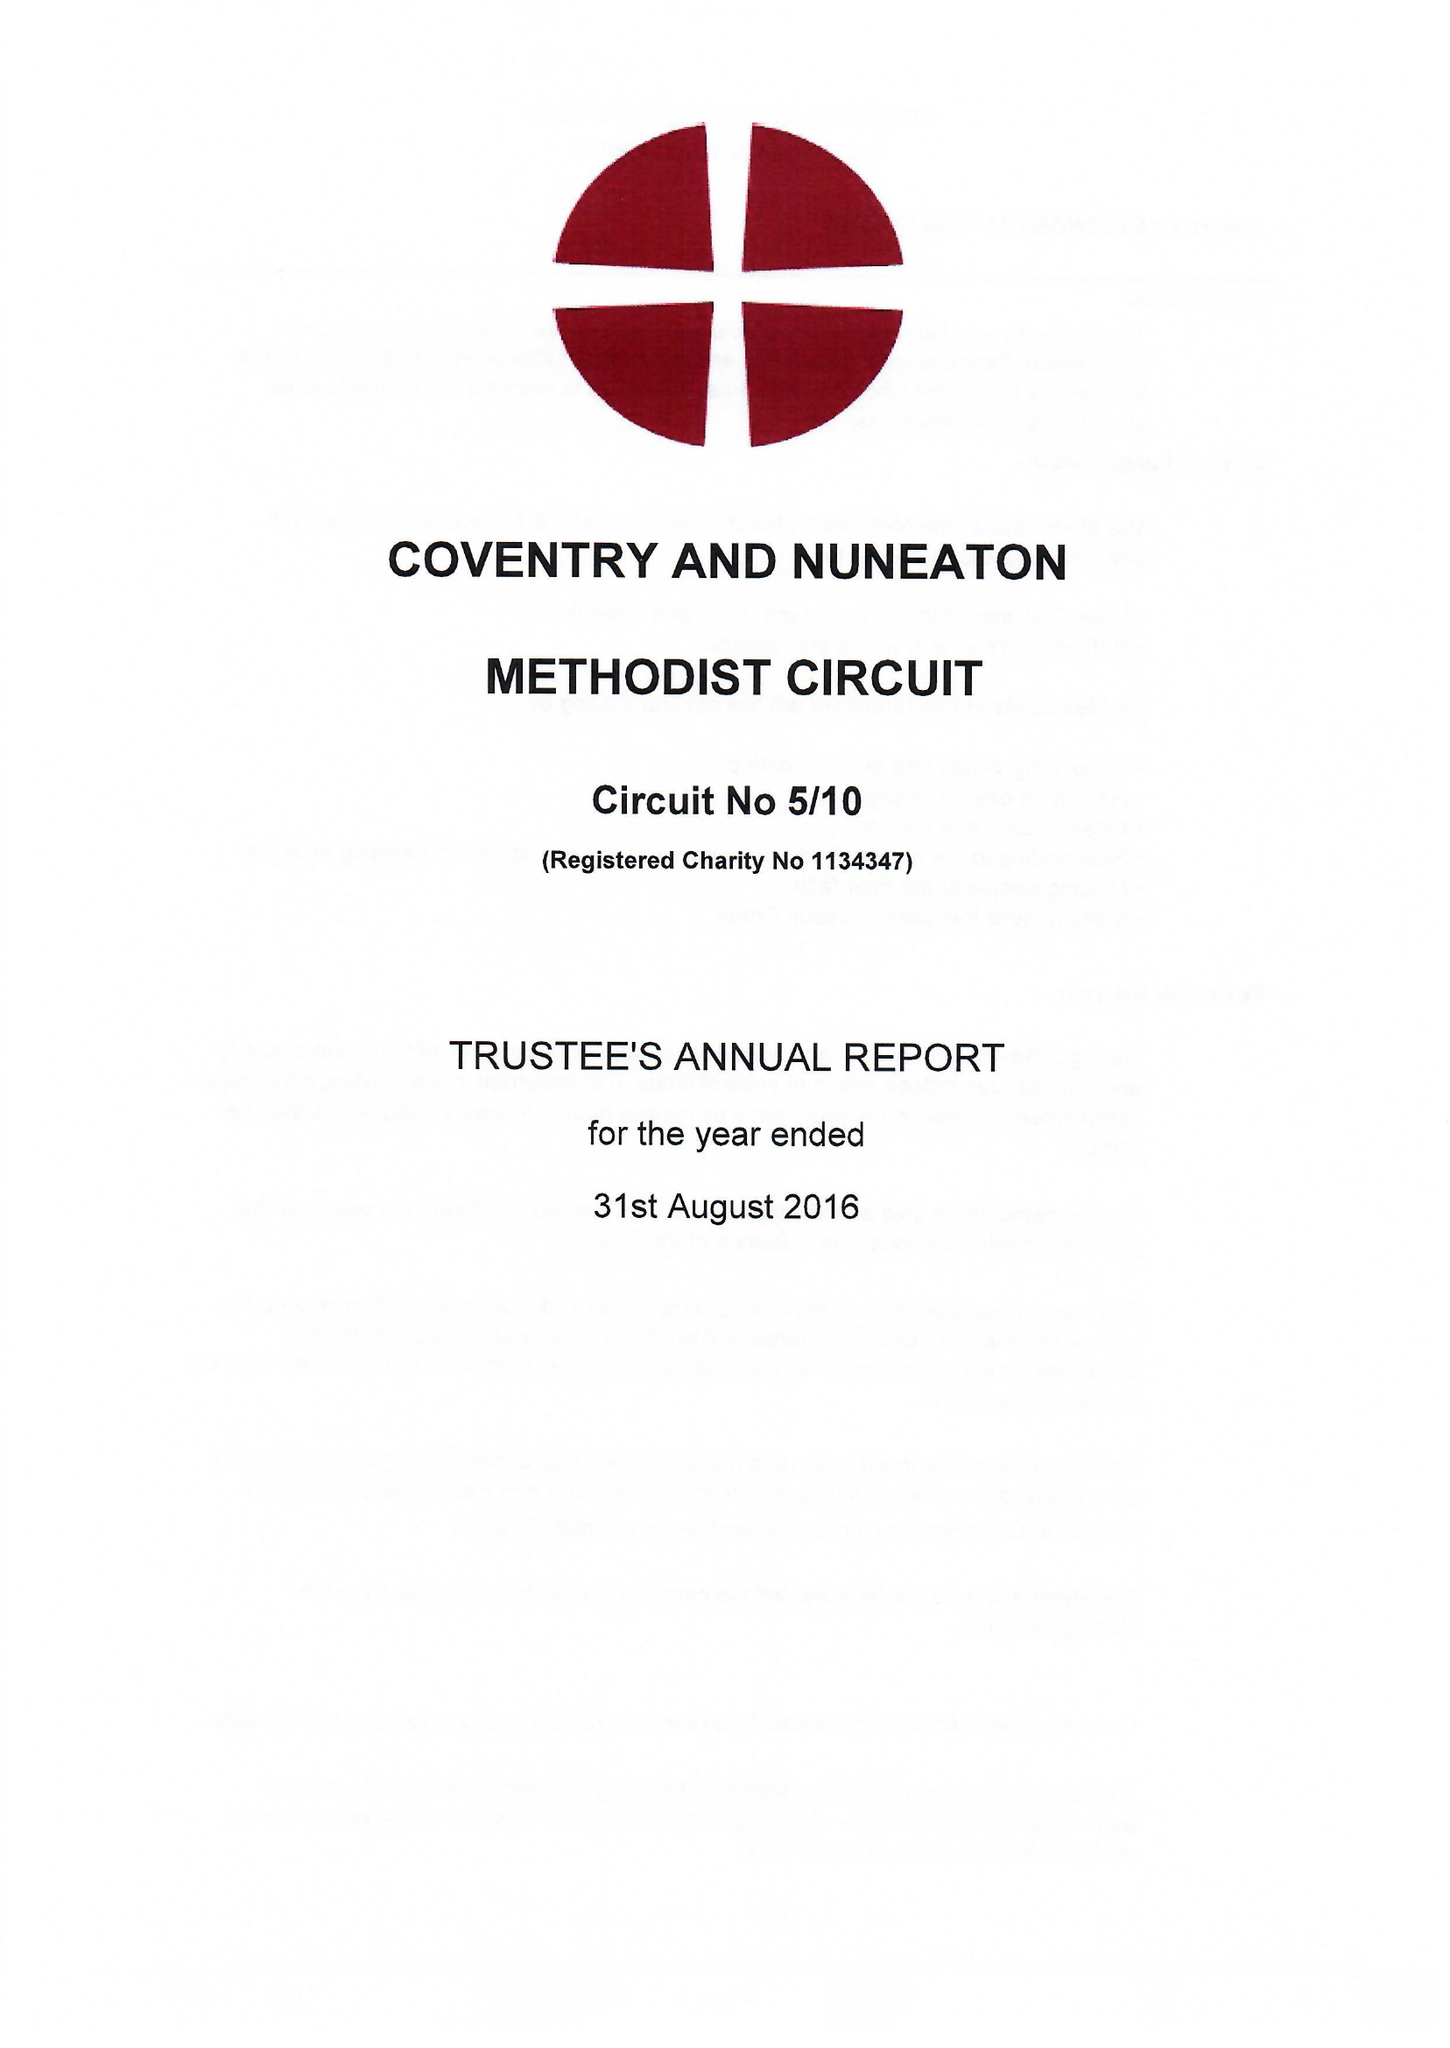What is the value for the address__postcode?
Answer the question using a single word or phrase. CV1 2HA 